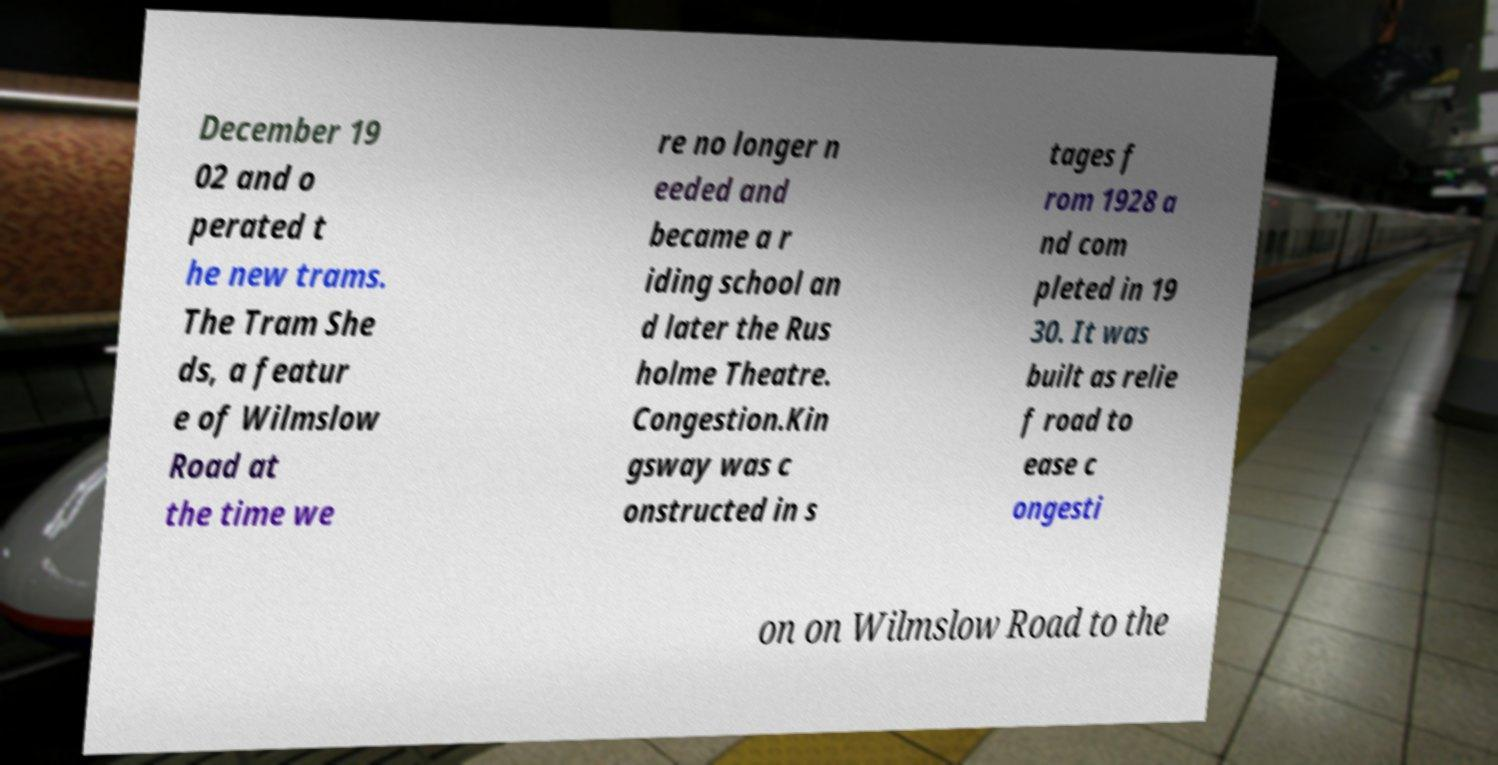What messages or text are displayed in this image? I need them in a readable, typed format. December 19 02 and o perated t he new trams. The Tram She ds, a featur e of Wilmslow Road at the time we re no longer n eeded and became a r iding school an d later the Rus holme Theatre. Congestion.Kin gsway was c onstructed in s tages f rom 1928 a nd com pleted in 19 30. It was built as relie f road to ease c ongesti on on Wilmslow Road to the 